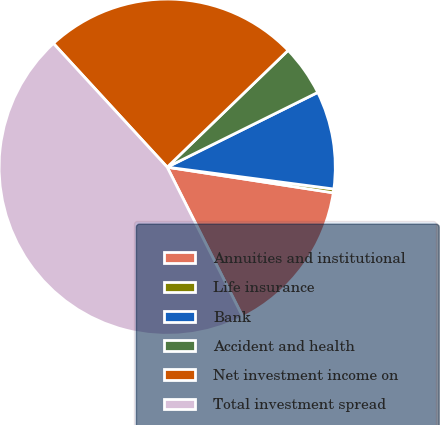Convert chart to OTSL. <chart><loc_0><loc_0><loc_500><loc_500><pie_chart><fcel>Annuities and institutional<fcel>Life insurance<fcel>Bank<fcel>Accident and health<fcel>Net investment income on<fcel>Total investment spread<nl><fcel>15.12%<fcel>0.36%<fcel>9.41%<fcel>4.89%<fcel>24.61%<fcel>45.61%<nl></chart> 